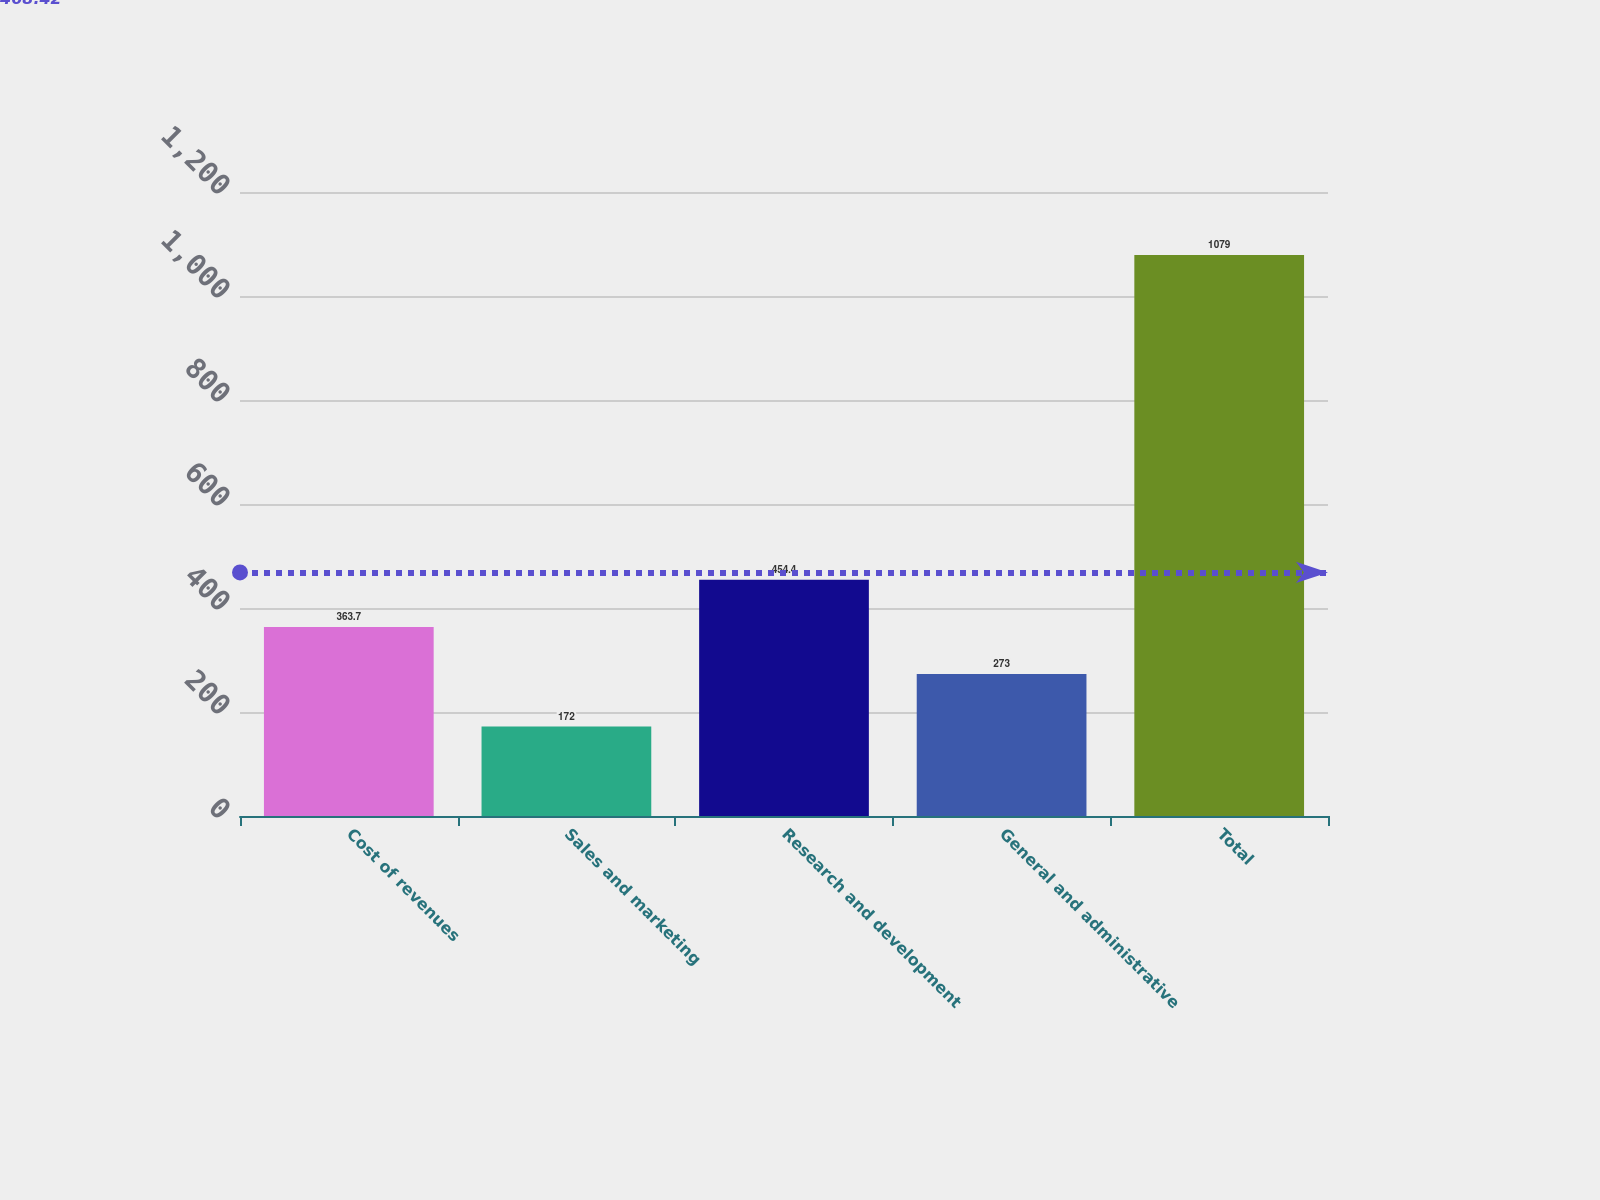<chart> <loc_0><loc_0><loc_500><loc_500><bar_chart><fcel>Cost of revenues<fcel>Sales and marketing<fcel>Research and development<fcel>General and administrative<fcel>Total<nl><fcel>363.7<fcel>172<fcel>454.4<fcel>273<fcel>1079<nl></chart> 